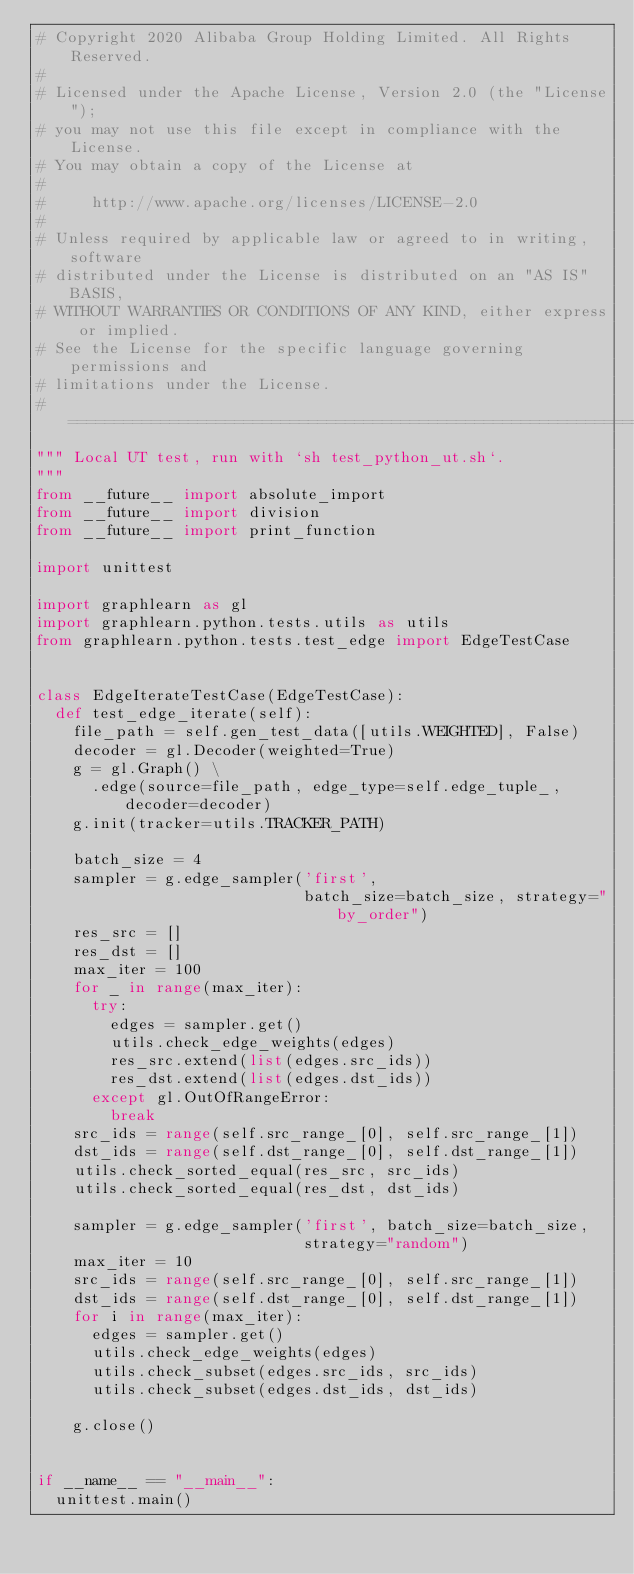Convert code to text. <code><loc_0><loc_0><loc_500><loc_500><_Python_># Copyright 2020 Alibaba Group Holding Limited. All Rights Reserved.
#
# Licensed under the Apache License, Version 2.0 (the "License");
# you may not use this file except in compliance with the License.
# You may obtain a copy of the License at
#
#     http://www.apache.org/licenses/LICENSE-2.0
#
# Unless required by applicable law or agreed to in writing, software
# distributed under the License is distributed on an "AS IS" BASIS,
# WITHOUT WARRANTIES OR CONDITIONS OF ANY KIND, either express or implied.
# See the License for the specific language governing permissions and
# limitations under the License.
# =============================================================================
""" Local UT test, run with `sh test_python_ut.sh`.
"""
from __future__ import absolute_import
from __future__ import division
from __future__ import print_function

import unittest

import graphlearn as gl
import graphlearn.python.tests.utils as utils
from graphlearn.python.tests.test_edge import EdgeTestCase


class EdgeIterateTestCase(EdgeTestCase):
  def test_edge_iterate(self):
    file_path = self.gen_test_data([utils.WEIGHTED], False)
    decoder = gl.Decoder(weighted=True)
    g = gl.Graph() \
      .edge(source=file_path, edge_type=self.edge_tuple_, decoder=decoder)
    g.init(tracker=utils.TRACKER_PATH)

    batch_size = 4
    sampler = g.edge_sampler('first',
                             batch_size=batch_size, strategy="by_order")
    res_src = []
    res_dst = []
    max_iter = 100
    for _ in range(max_iter):
      try:
        edges = sampler.get()
        utils.check_edge_weights(edges)
        res_src.extend(list(edges.src_ids))
        res_dst.extend(list(edges.dst_ids))
      except gl.OutOfRangeError:
        break
    src_ids = range(self.src_range_[0], self.src_range_[1])
    dst_ids = range(self.dst_range_[0], self.dst_range_[1])
    utils.check_sorted_equal(res_src, src_ids)
    utils.check_sorted_equal(res_dst, dst_ids)

    sampler = g.edge_sampler('first', batch_size=batch_size,
                             strategy="random")
    max_iter = 10
    src_ids = range(self.src_range_[0], self.src_range_[1])
    dst_ids = range(self.dst_range_[0], self.dst_range_[1])
    for i in range(max_iter):
      edges = sampler.get()
      utils.check_edge_weights(edges)
      utils.check_subset(edges.src_ids, src_ids)
      utils.check_subset(edges.dst_ids, dst_ids)

    g.close()


if __name__ == "__main__":
  unittest.main()
</code> 